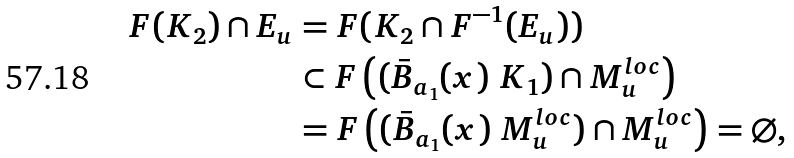<formula> <loc_0><loc_0><loc_500><loc_500>F ( K _ { 2 } ) \cap E _ { u } & = F ( K _ { 2 } \cap F ^ { - 1 } ( E _ { u } ) ) \\ & \subset F \left ( ( \bar { B } _ { a _ { 1 } } ( x ) \ K _ { 1 } ) \cap M _ { u } ^ { l o c } \right ) \\ & = F \left ( ( \bar { B } _ { a _ { 1 } } ( x ) \ M _ { u } ^ { l o c } ) \cap M _ { u } ^ { l o c } \right ) = \varnothing ,</formula> 